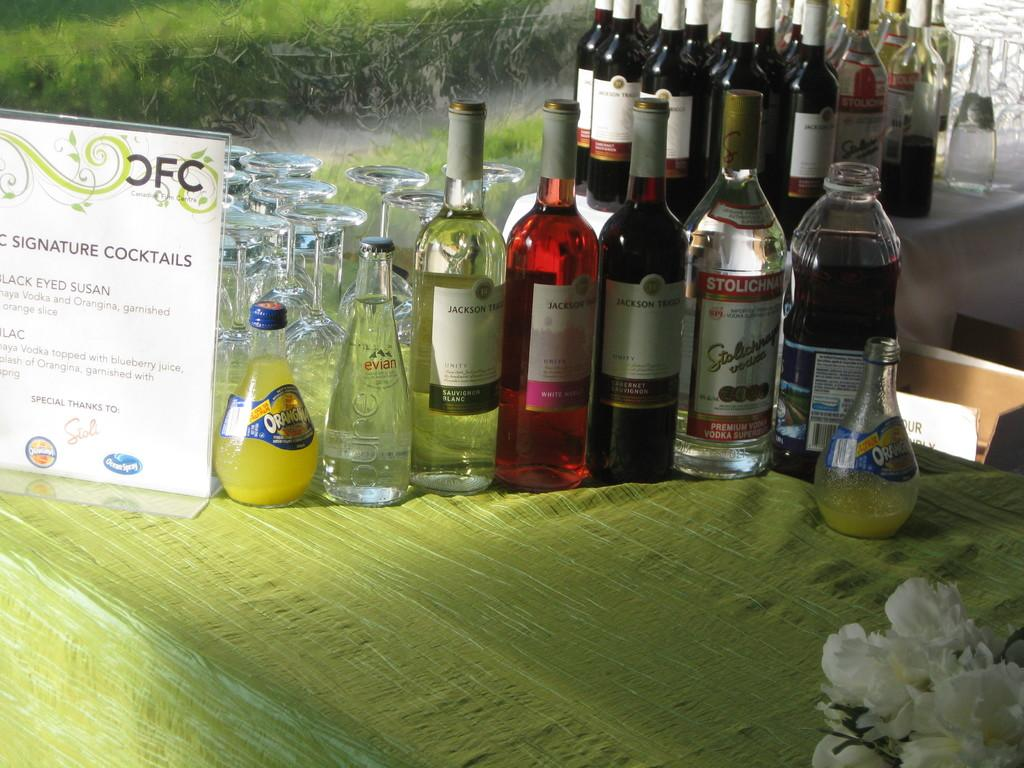<image>
Relay a brief, clear account of the picture shown. Many bottles together with one that says "Stolichna" on it. 